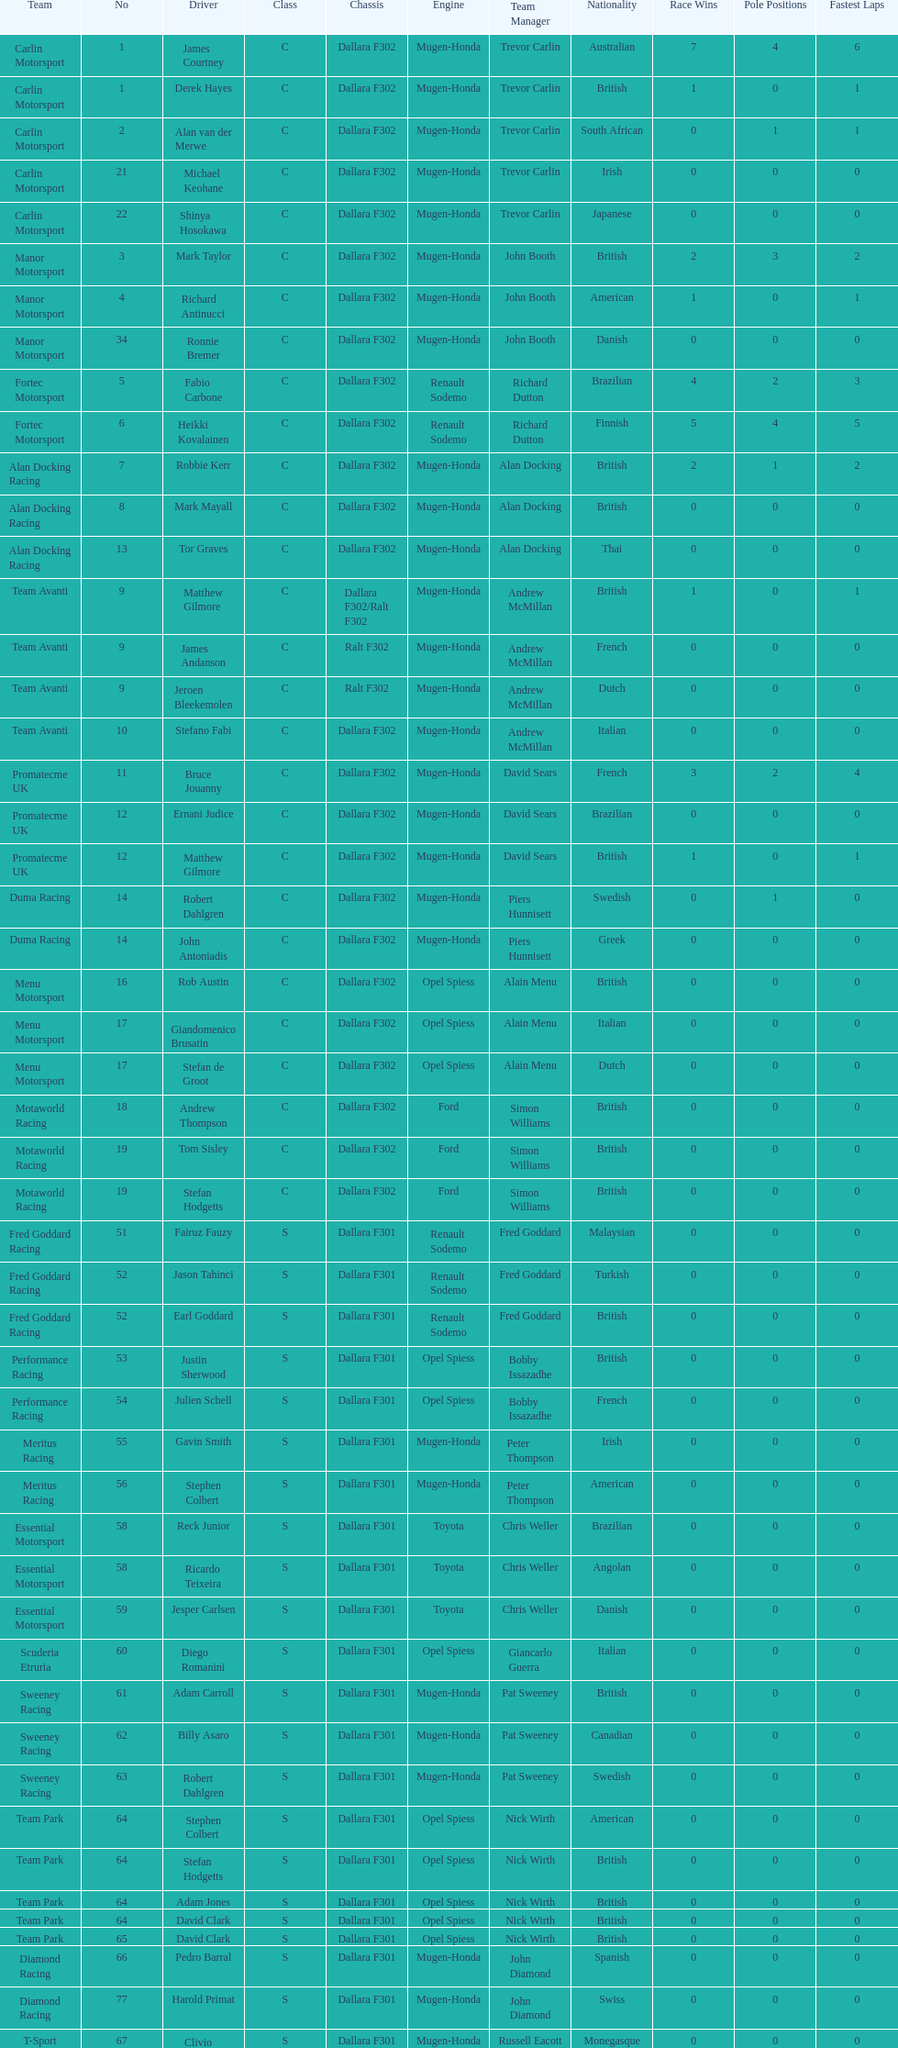What is the total number of class c (championship) teams? 21. 